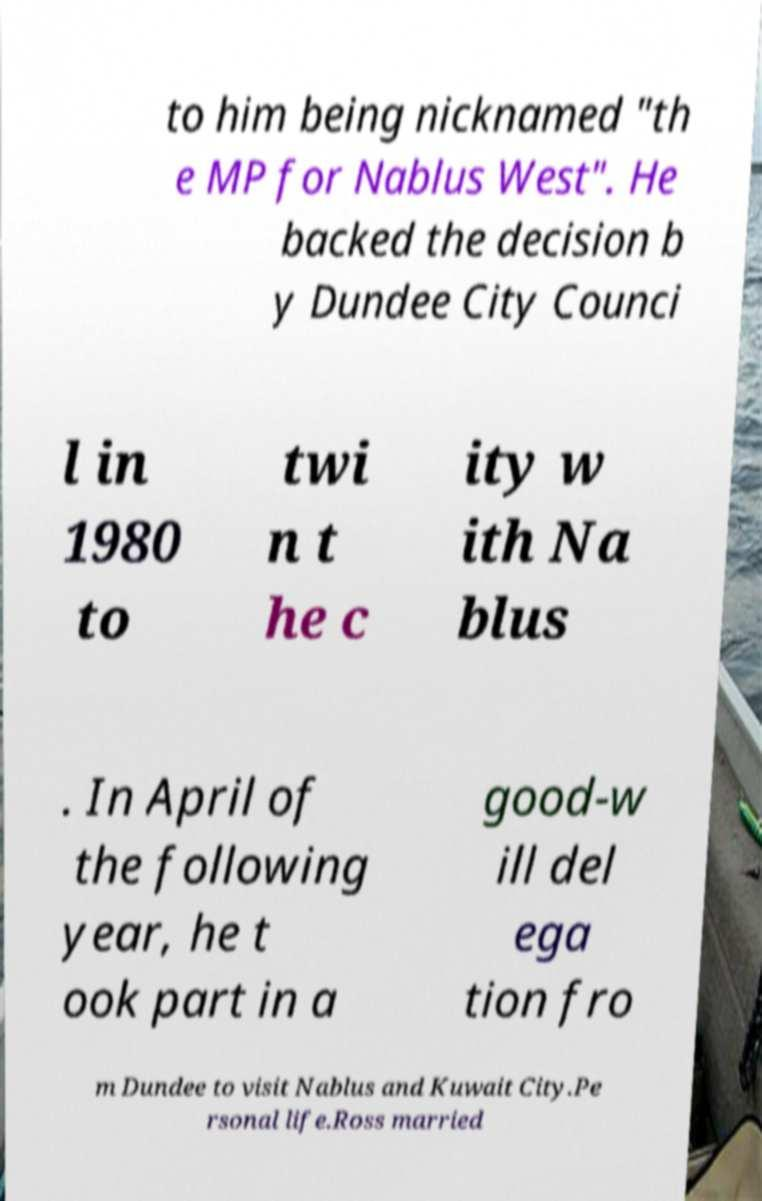Please read and relay the text visible in this image. What does it say? to him being nicknamed "th e MP for Nablus West". He backed the decision b y Dundee City Counci l in 1980 to twi n t he c ity w ith Na blus . In April of the following year, he t ook part in a good-w ill del ega tion fro m Dundee to visit Nablus and Kuwait City.Pe rsonal life.Ross married 